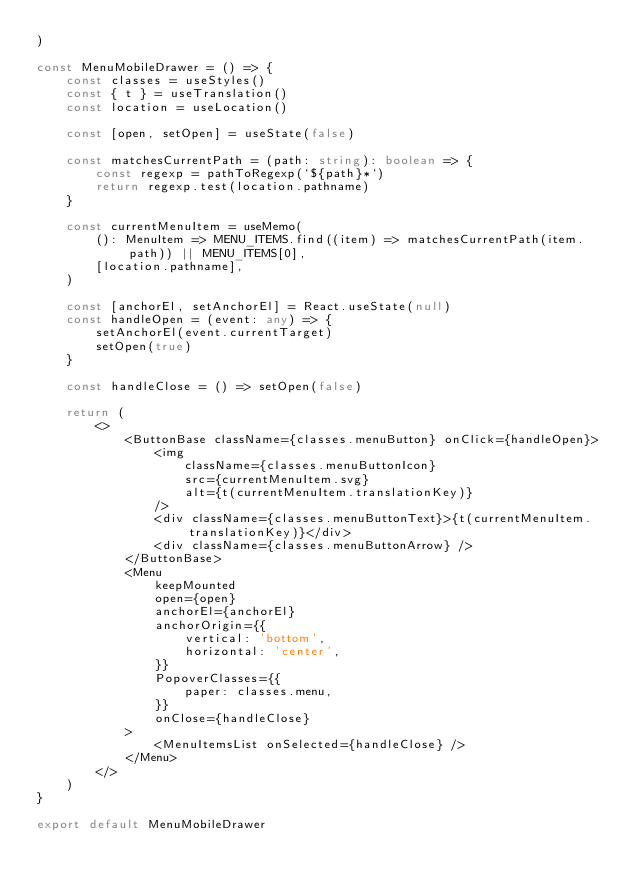Convert code to text. <code><loc_0><loc_0><loc_500><loc_500><_TypeScript_>)

const MenuMobileDrawer = () => {
    const classes = useStyles()
    const { t } = useTranslation()
    const location = useLocation()

    const [open, setOpen] = useState(false)

    const matchesCurrentPath = (path: string): boolean => {
        const regexp = pathToRegexp(`${path}*`)
        return regexp.test(location.pathname)
    }

    const currentMenuItem = useMemo(
        (): MenuItem => MENU_ITEMS.find((item) => matchesCurrentPath(item.path)) || MENU_ITEMS[0],
        [location.pathname],
    )

    const [anchorEl, setAnchorEl] = React.useState(null)
    const handleOpen = (event: any) => {
        setAnchorEl(event.currentTarget)
        setOpen(true)
    }

    const handleClose = () => setOpen(false)

    return (
        <>
            <ButtonBase className={classes.menuButton} onClick={handleOpen}>
                <img
                    className={classes.menuButtonIcon}
                    src={currentMenuItem.svg}
                    alt={t(currentMenuItem.translationKey)}
                />
                <div className={classes.menuButtonText}>{t(currentMenuItem.translationKey)}</div>
                <div className={classes.menuButtonArrow} />
            </ButtonBase>
            <Menu
                keepMounted
                open={open}
                anchorEl={anchorEl}
                anchorOrigin={{
                    vertical: 'bottom',
                    horizontal: 'center',
                }}
                PopoverClasses={{
                    paper: classes.menu,
                }}
                onClose={handleClose}
            >
                <MenuItemsList onSelected={handleClose} />
            </Menu>
        </>
    )
}

export default MenuMobileDrawer
</code> 